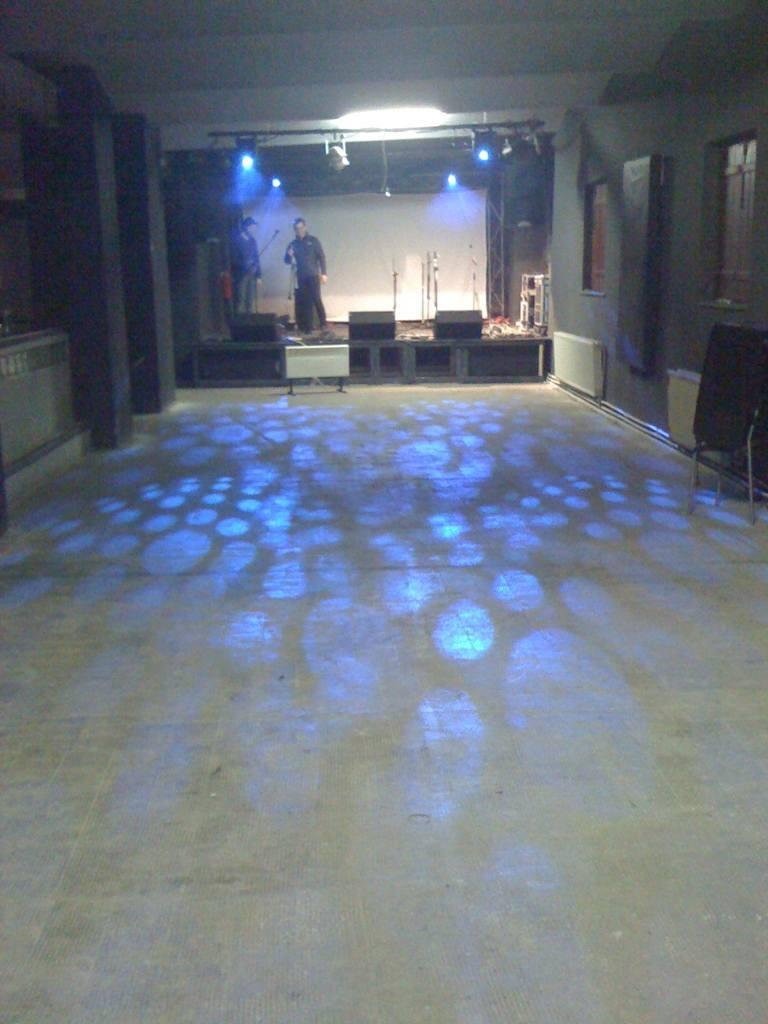How many people are present in the image? There are two persons standing in the image. What can be seen illuminated in the image? There are lights visible in the image. What architectural features can be seen in the image? There are windows visible in the image. What is the color of the background in the image? The background of the image is white. What type of road can be seen in the image? There is no road visible in the image. Is there a rake being used by one of the persons in the image? There is no rake present in the image. 